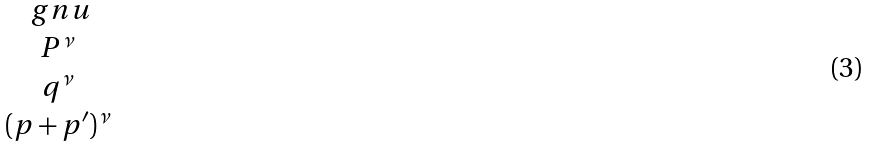Convert formula to latex. <formula><loc_0><loc_0><loc_500><loc_500>\begin{matrix} \ g n u \\ P ^ { \nu } \\ q ^ { \nu } \\ ( p + p ^ { \prime } ) ^ { \nu } \end{matrix}</formula> 